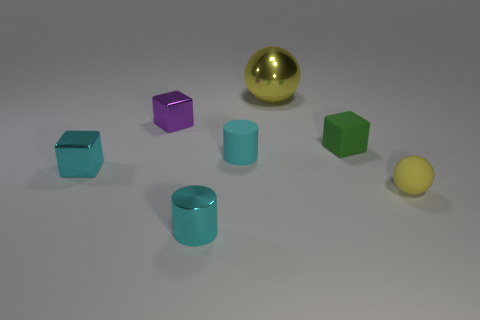Subtract all red blocks. Subtract all gray balls. How many blocks are left? 3 Add 3 yellow rubber balls. How many objects exist? 10 Subtract all cylinders. How many objects are left? 5 Subtract all small cubes. Subtract all large gray matte objects. How many objects are left? 4 Add 3 metallic cylinders. How many metallic cylinders are left? 4 Add 6 gray rubber cylinders. How many gray rubber cylinders exist? 6 Subtract 0 yellow blocks. How many objects are left? 7 